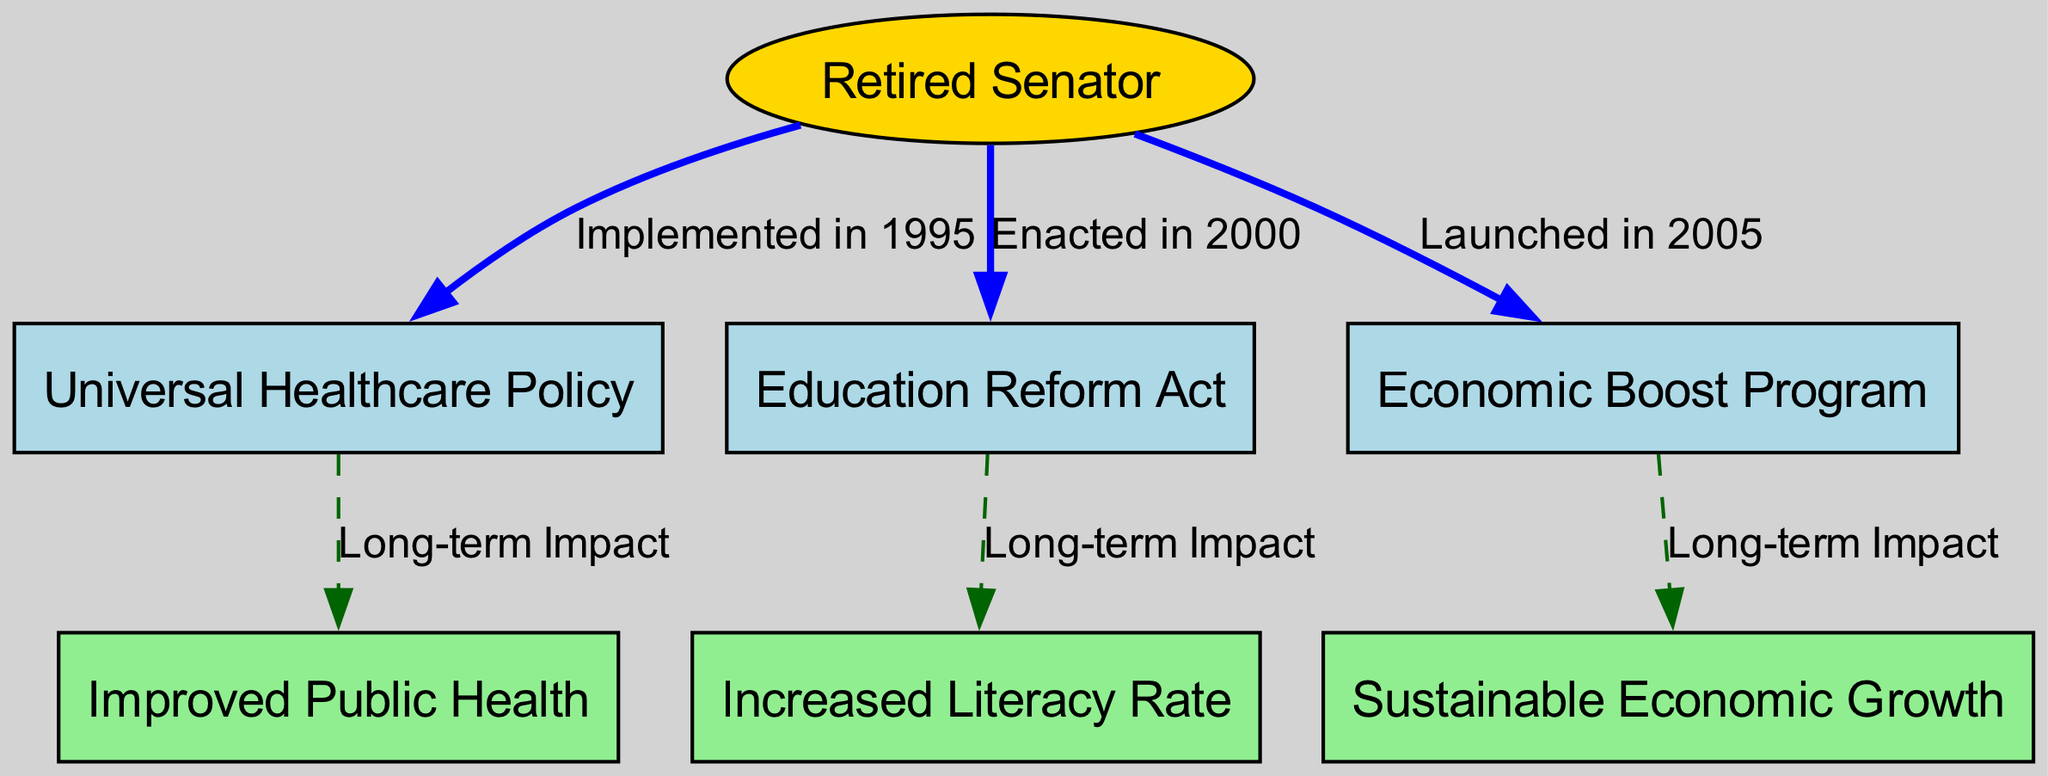What major policy did the senator implement in 1995? According to the diagram, the node "healthcarePolicy" is connected to the "senator" node with an edge labeled "Implemented in 1995." This indicates that the major policy implemented by the senator in that year was the Universal Healthcare Policy.
Answer: Universal Healthcare Policy How many nodes are there in the diagram? The diagram consists of a total of 7 nodes: 1 node for the senator, 3 policy nodes, and 3 long-term impact nodes. Counting these gives us 7 nodes.
Answer: 7 What long-term impact is associated with the Economic Boost Program? The "economicBoost" node connects to the "longTermEconomicImpact" node with an edge labeled "Long-term Impact." This shows that the long-term impact associated with the Economic Boost Program is sustainable economic growth.
Answer: Sustainable Economic Growth What relationship exists between the Education Reform Act and increased literacy rate? From the diagram, the "educationReform" node connects to the "longTermEducationImpact" node with the edge labeled "Long-term Impact." This indicates a direct relationship where the Education Reform Act contributes to increased literacy rate.
Answer: Long-term Impact Which policy was enacted in 2000? The diagram shows that the "educationReform" node is connected to the "senator" node by an edge labeled "Enacted in 2000." Therefore, the policy enacted in 2000 was the Education Reform Act.
Answer: Education Reform Act What is a common characteristic of the edges labeled "Long-term Impact"? The edges that connect the policy nodes to their respective impact nodes are labeled "Long-term Impact," indicating they all describe the significant and enduring effects of the initial policies implemented by the senator. This highlights a theme of lasting change resulting from the senator's actions.
Answer: Long-term Impact Which policy launched in 2005 relates to sustainable economic growth? The "economicBoost" node, which connects to "longTermEconomicImpact," shows that it was launched in 2005 and is associated with sustainable economic growth. This connection further clarifies the specific policy and its outcomes.
Answer: Economic Boost Program 